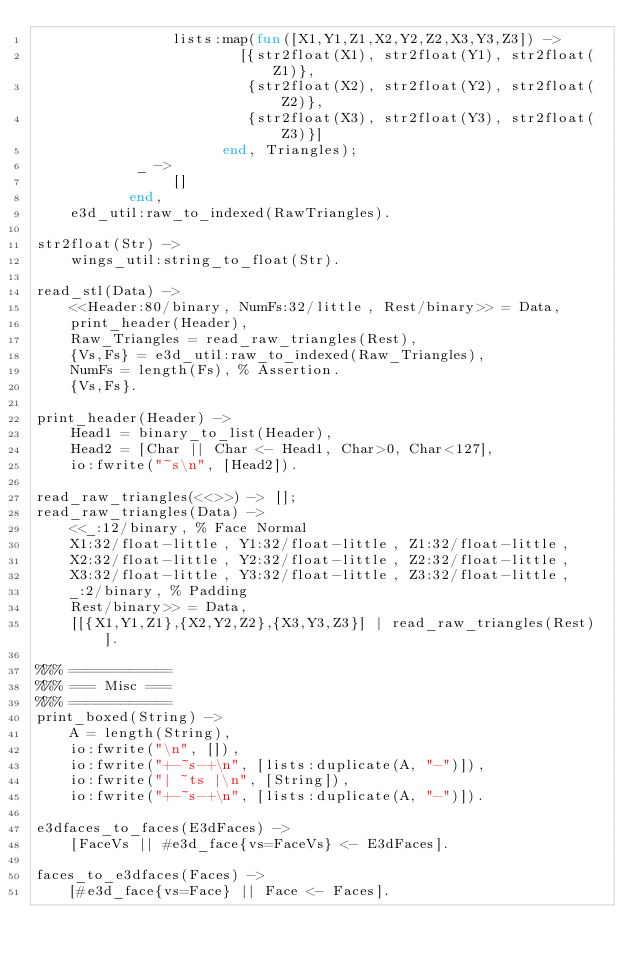<code> <loc_0><loc_0><loc_500><loc_500><_Erlang_>			    lists:map(fun([X1,Y1,Z1,X2,Y2,Z2,X3,Y3,Z3]) ->
					    [{str2float(X1), str2float(Y1), str2float(Z1)},
					     {str2float(X2), str2float(Y2), str2float(Z2)},
					     {str2float(X3), str2float(Y3), str2float(Z3)}]
				      end, Triangles);
			_ ->
			    []
		   end,
    e3d_util:raw_to_indexed(RawTriangles).

str2float(Str) ->
    wings_util:string_to_float(Str).

read_stl(Data) ->
    <<Header:80/binary, NumFs:32/little, Rest/binary>> = Data,
    print_header(Header),
    Raw_Triangles = read_raw_triangles(Rest),
    {Vs,Fs} = e3d_util:raw_to_indexed(Raw_Triangles),
    NumFs = length(Fs), % Assertion.
    {Vs,Fs}.

print_header(Header) ->
    Head1 = binary_to_list(Header),
    Head2 = [Char || Char <- Head1, Char>0, Char<127],
    io:fwrite("~s\n", [Head2]).

read_raw_triangles(<<>>) -> [];
read_raw_triangles(Data) ->
    <<_:12/binary, % Face Normal
    X1:32/float-little, Y1:32/float-little, Z1:32/float-little,
    X2:32/float-little, Y2:32/float-little, Z2:32/float-little,
    X3:32/float-little, Y3:32/float-little, Z3:32/float-little,
    _:2/binary, % Padding
    Rest/binary>> = Data,
    [[{X1,Y1,Z1},{X2,Y2,Z2},{X3,Y3,Z3}] | read_raw_triangles(Rest)].

%%% ============
%%% === Misc ===
%%% ============
print_boxed(String) ->
    A = length(String),
    io:fwrite("\n", []),
    io:fwrite("+-~s-+\n", [lists:duplicate(A, "-")]),
    io:fwrite("| ~ts |\n", [String]),
    io:fwrite("+-~s-+\n", [lists:duplicate(A, "-")]).

e3dfaces_to_faces(E3dFaces) ->
    [FaceVs || #e3d_face{vs=FaceVs} <- E3dFaces].

faces_to_e3dfaces(Faces) ->
    [#e3d_face{vs=Face} || Face <- Faces].

</code> 